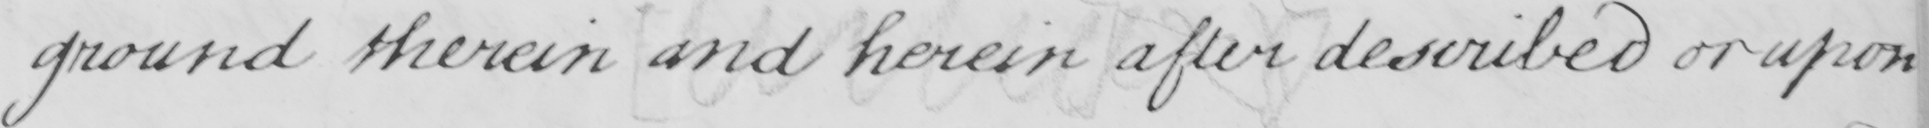What is written in this line of handwriting? ground therein and herein after described or upon 